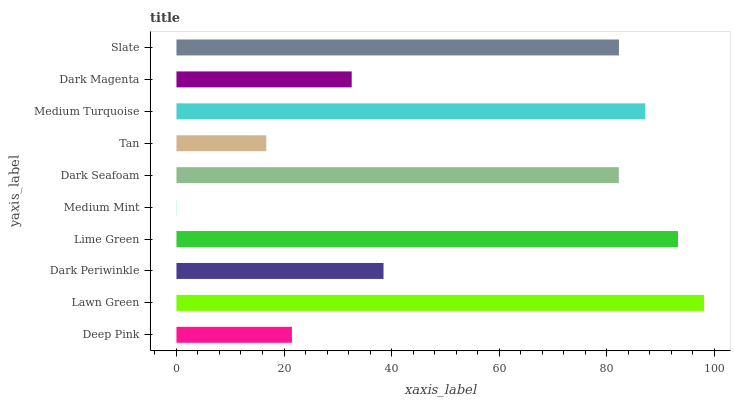Is Medium Mint the minimum?
Answer yes or no. Yes. Is Lawn Green the maximum?
Answer yes or no. Yes. Is Dark Periwinkle the minimum?
Answer yes or no. No. Is Dark Periwinkle the maximum?
Answer yes or no. No. Is Lawn Green greater than Dark Periwinkle?
Answer yes or no. Yes. Is Dark Periwinkle less than Lawn Green?
Answer yes or no. Yes. Is Dark Periwinkle greater than Lawn Green?
Answer yes or no. No. Is Lawn Green less than Dark Periwinkle?
Answer yes or no. No. Is Dark Seafoam the high median?
Answer yes or no. Yes. Is Dark Periwinkle the low median?
Answer yes or no. Yes. Is Tan the high median?
Answer yes or no. No. Is Dark Magenta the low median?
Answer yes or no. No. 